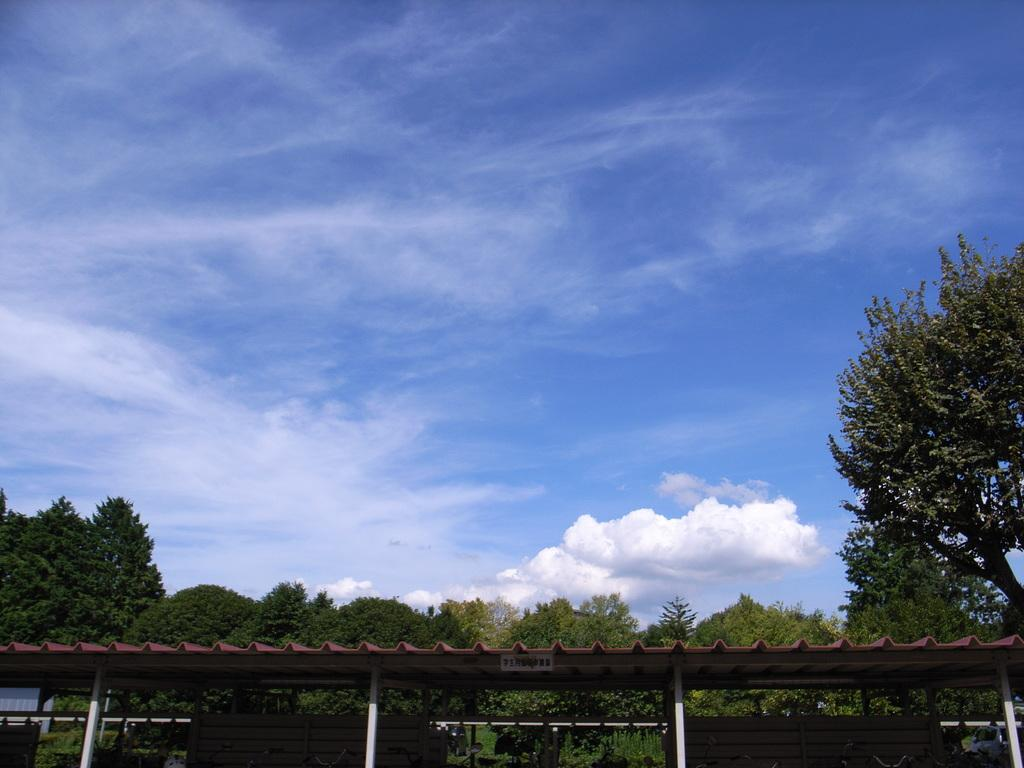What is visible in the foreground of the image? The roof is visible in the foreground of the image. What can be seen in the background of the image? There are trees in the background of the image. What is present in the sky in the image? Clouds are present in the sky. Can you tell me how many snakes are slithering on the roof in the image? There are no snakes present in the image; the roof is visible without any snakes. Who is the representative of the trees in the background of the image? There is no representative of the trees in the image, as trees do not have representatives. 